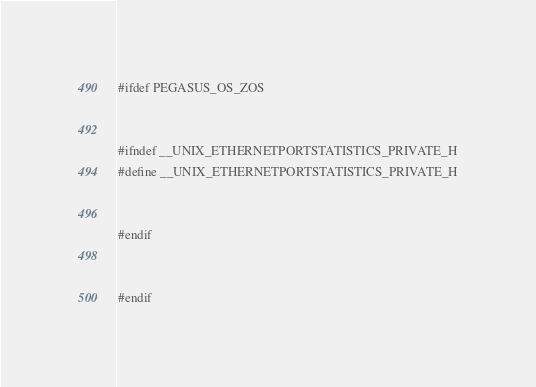Convert code to text. <code><loc_0><loc_0><loc_500><loc_500><_C++_>#ifdef PEGASUS_OS_ZOS


#ifndef __UNIX_ETHERNETPORTSTATISTICS_PRIVATE_H
#define __UNIX_ETHERNETPORTSTATISTICS_PRIVATE_H


#endif


#endif
</code> 